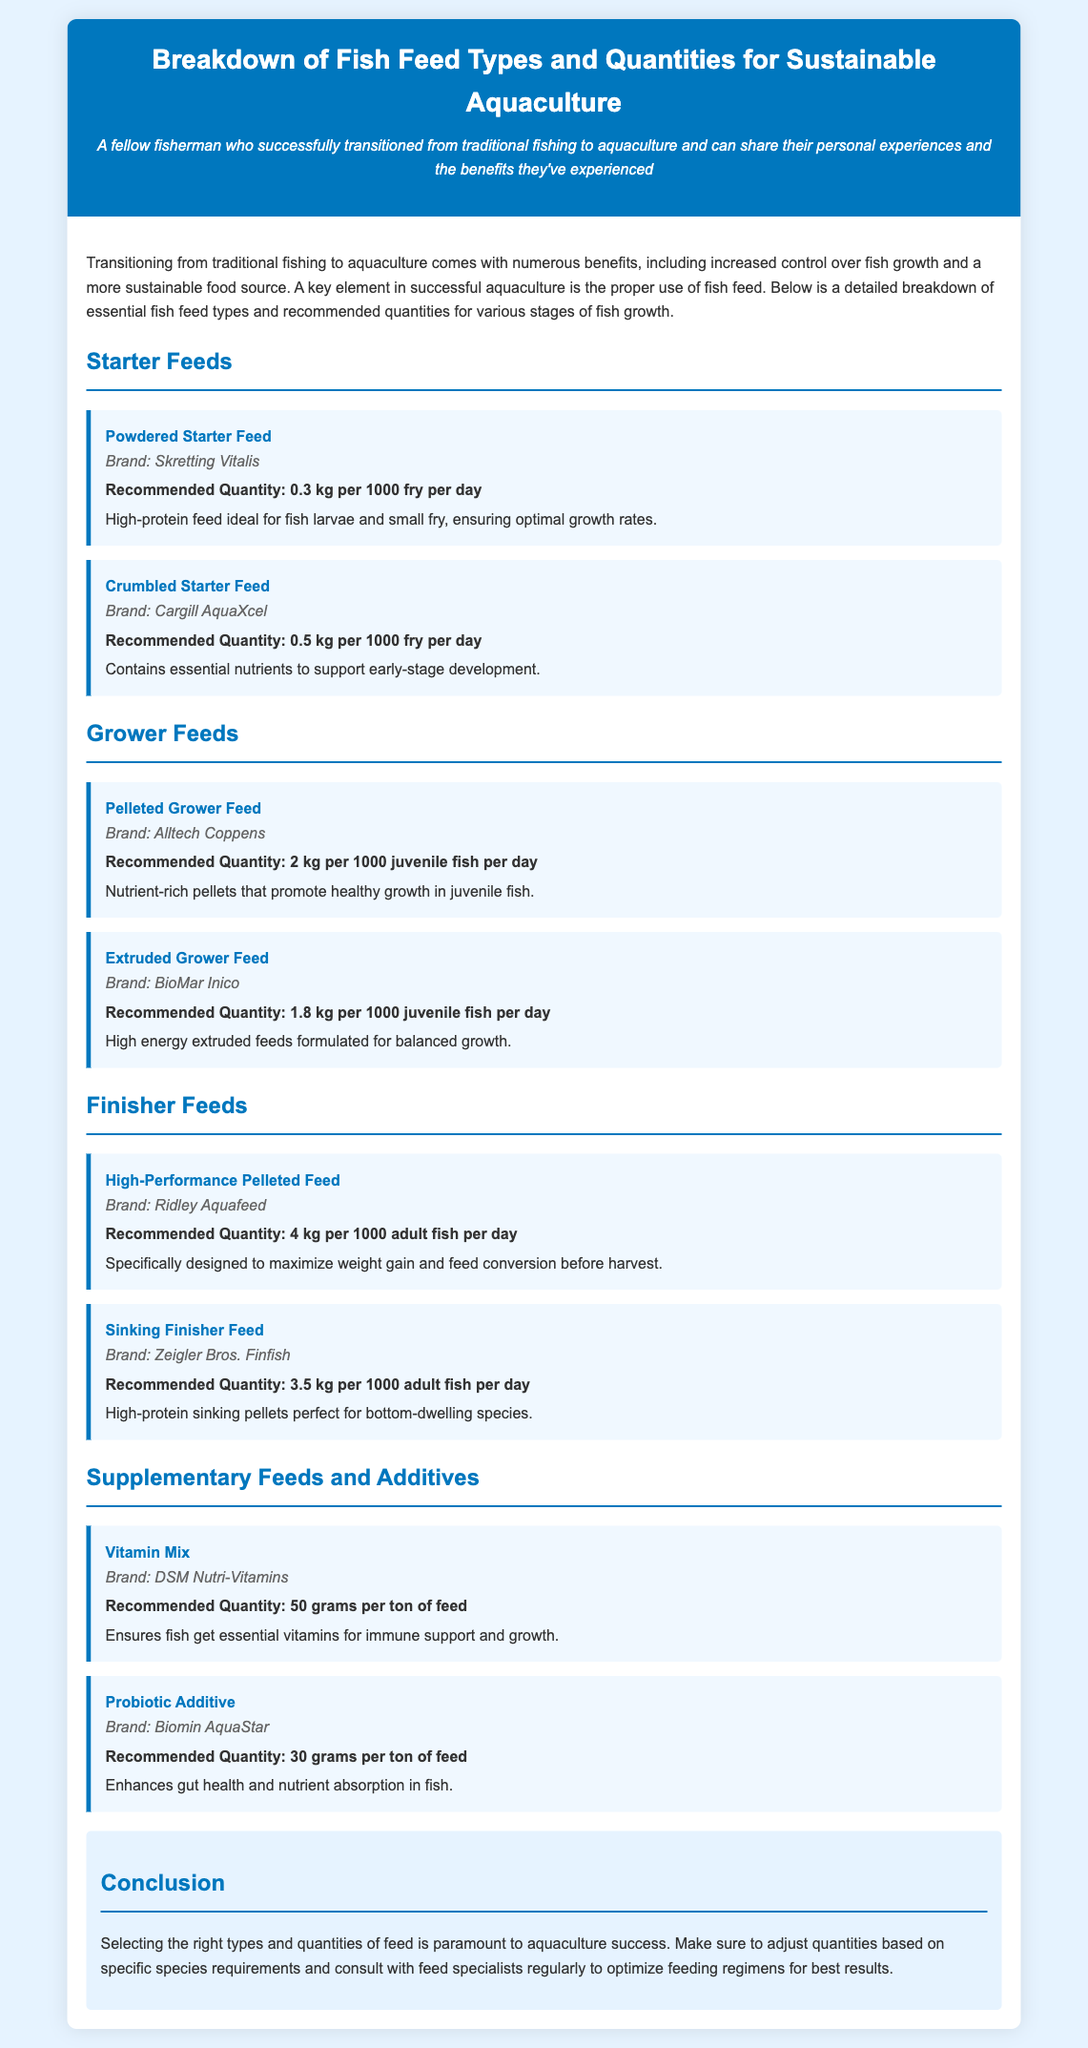What is the brand of the Powdered Starter Feed? The document lists the brand of Powdered Starter Feed as Skretting Vitalis.
Answer: Skretting Vitalis What is the recommended quantity for Crumbled Starter Feed? The recommended quantity for Crumbled Starter Feed is stated in the document as 0.5 kg per 1000 fry per day.
Answer: 0.5 kg per 1000 fry per day What type of feed is formulated for balanced growth? The document mentions "Extruded Grower Feed" as being high energy and formulated for balanced growth.
Answer: Extruded Grower Feed How many kilograms of High-Performance Pelleted Feed are recommended per 1000 adult fish? The document specifies that 4 kg of High-Performance Pelleted Feed is recommended per 1000 adult fish per day.
Answer: 4 kg per 1000 adult fish per day What additive enhances gut health in fish? The document refers to "Probiotic Additive" as an additive that enhances gut health and nutrient absorption in fish.
Answer: Probiotic Additive Which feed type contains essential nutrients for early-stage development? The feed type listed in the document that contains essential nutrients for early-stage development is "Crumbled Starter Feed."
Answer: Crumbled Starter Feed What is the main purpose of the Vitamin Mix according to the document? The document states that the Vitamin Mix ensures fish get essential vitamins for immune support and growth.
Answer: Immune support and growth What fish feed type is designed to maximize weight gain before harvest? The document mentions "High-Performance Pelleted Feed" as specifically designed to maximize weight gain before harvest.
Answer: High-Performance Pelleted Feed 